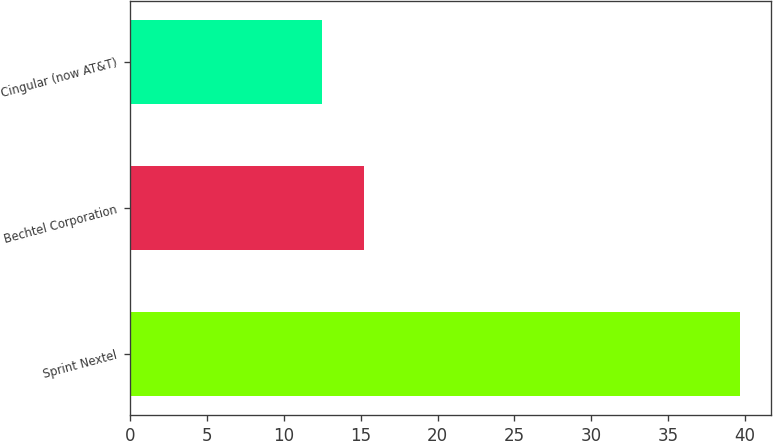<chart> <loc_0><loc_0><loc_500><loc_500><bar_chart><fcel>Sprint Nextel<fcel>Bechtel Corporation<fcel>Cingular (now AT&T)<nl><fcel>39.7<fcel>15.22<fcel>12.5<nl></chart> 